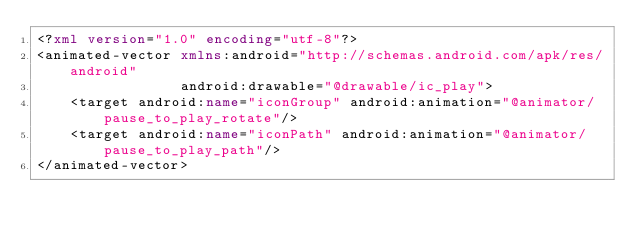<code> <loc_0><loc_0><loc_500><loc_500><_XML_><?xml version="1.0" encoding="utf-8"?>
<animated-vector xmlns:android="http://schemas.android.com/apk/res/android"
                 android:drawable="@drawable/ic_play">
    <target android:name="iconGroup" android:animation="@animator/pause_to_play_rotate"/>
    <target android:name="iconPath" android:animation="@animator/pause_to_play_path"/>
</animated-vector></code> 